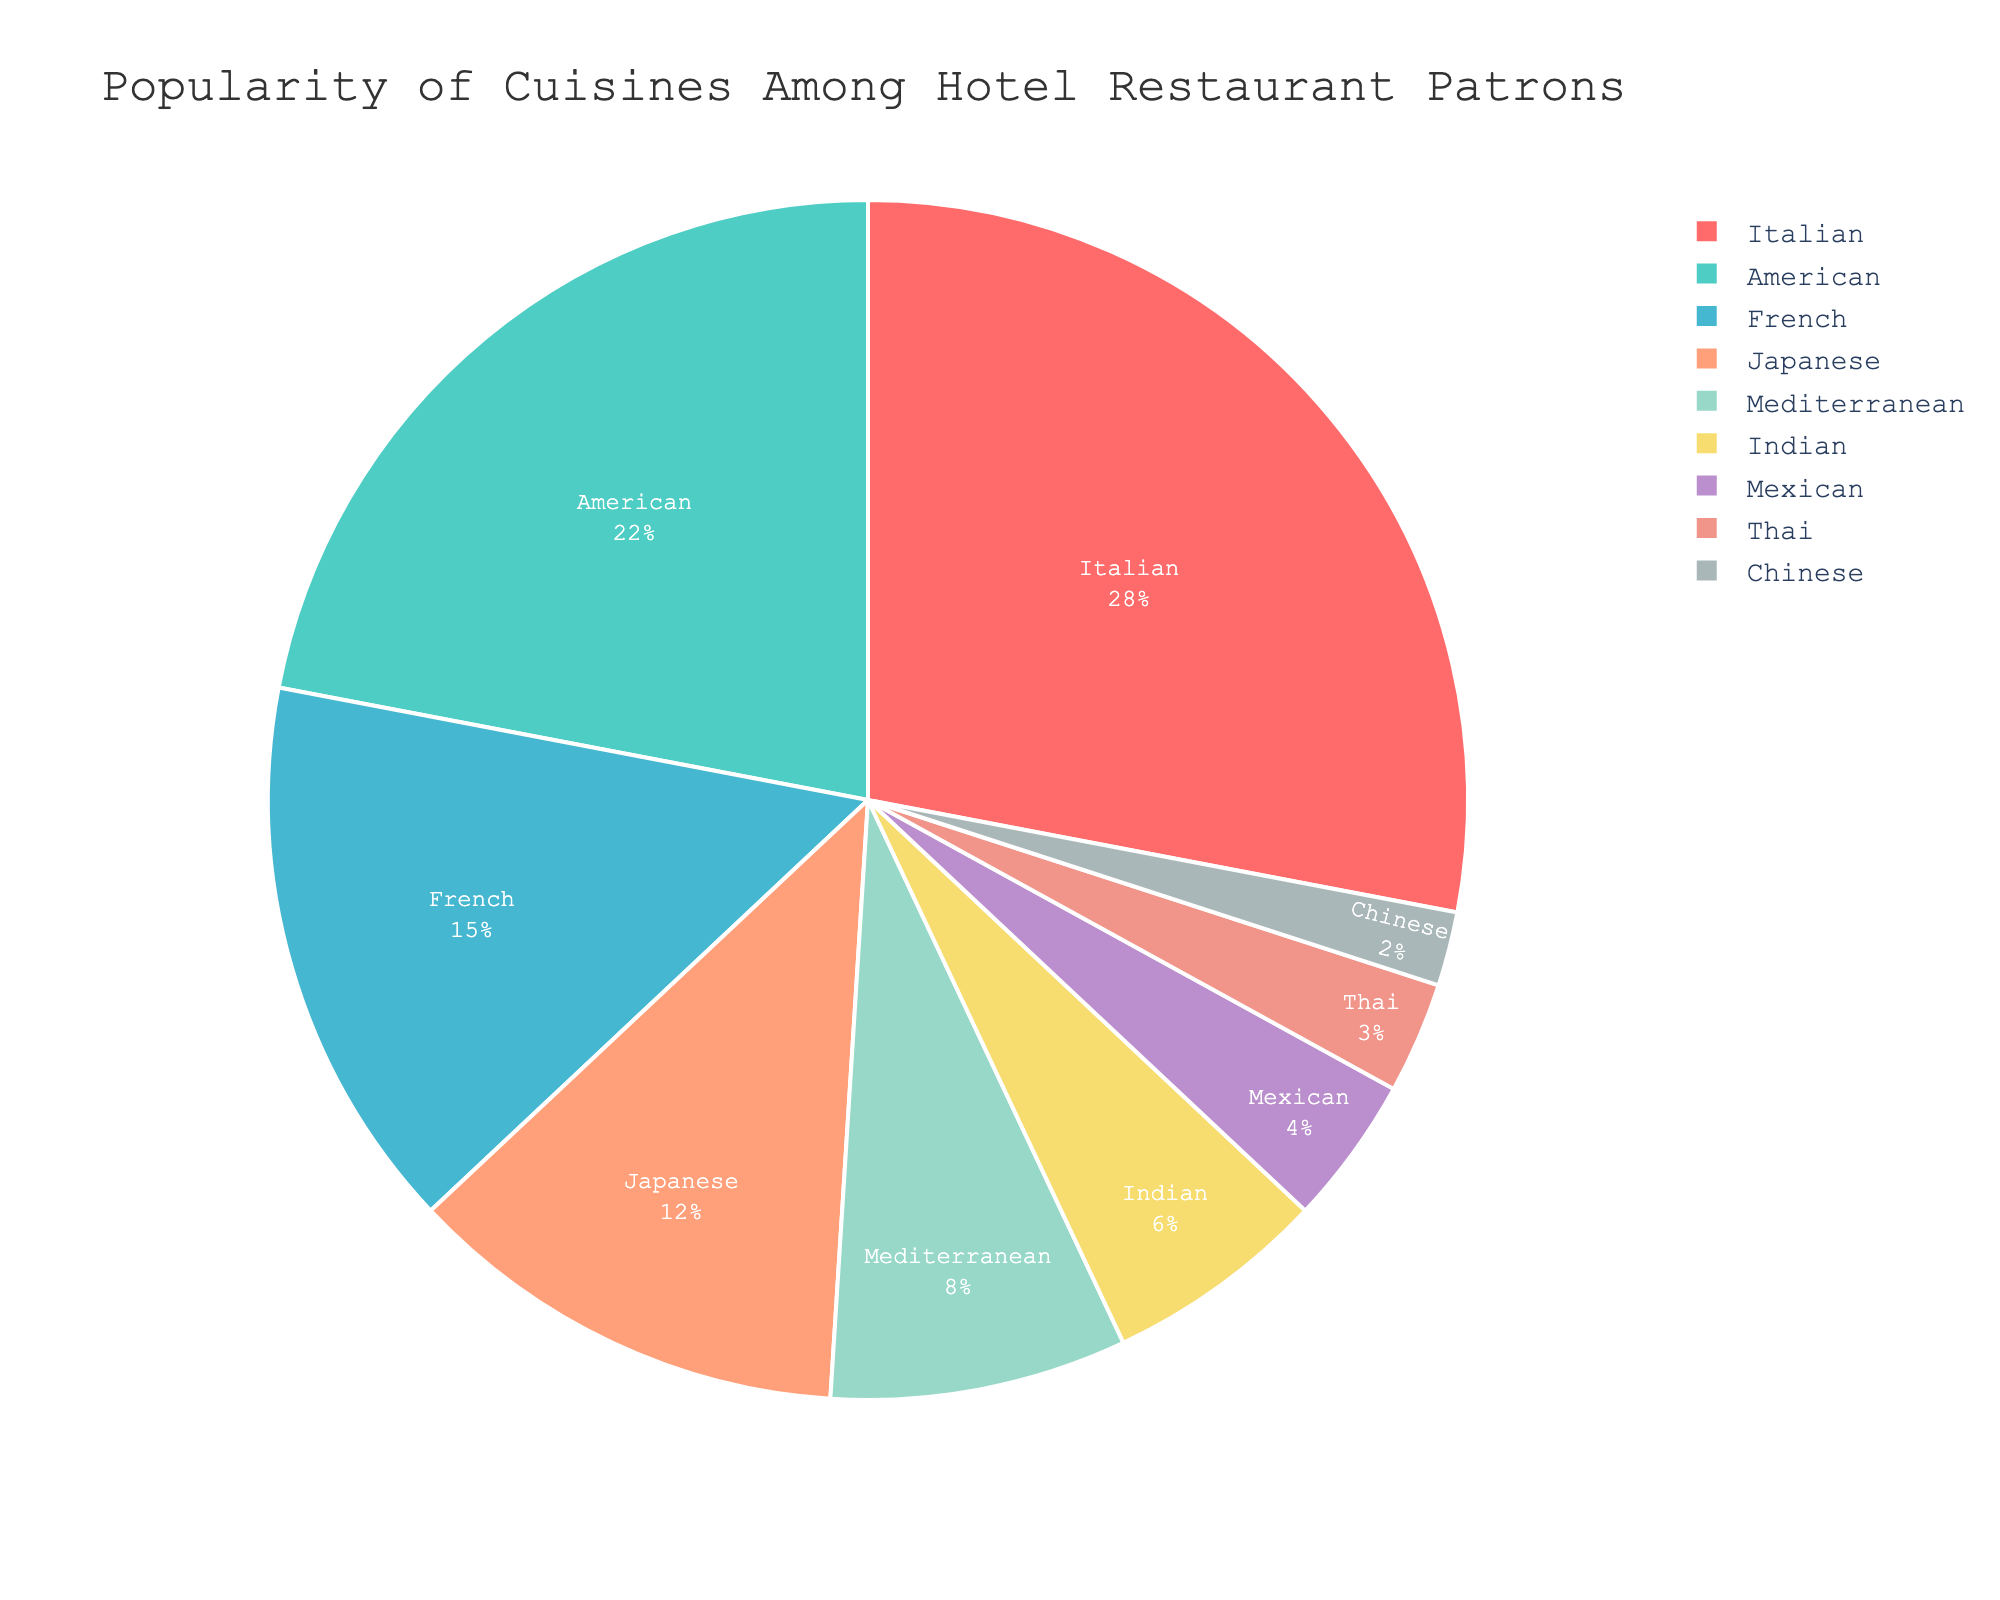How many cuisines have a popularity percentage lower than 10%? To find this, locate all the slices of the pie chart representing cuisines with percentages less than 10. These cuisines are Indian (6%), Mexican (4%), Thai (3%), and Chinese (2%). That makes a total of 4 cuisines.
Answer: 4 Which cuisine is the least popular among hotel restaurant patrons? The least popular cuisine will be the one with the smallest slice in the pie chart. According to the data, Chinese cuisine has the smallest percentage, which is 2%.
Answer: Chinese What is the combined popularity percentage of French and Japanese cuisines? To find the total popularity of French and Japanese cuisines, add their individual percentages: French (15%) + Japanese (12%) = 27%.
Answer: 27% Are there more patrons who prefer American cuisine than those who prefer Japanese and Mediterranean combined? First, check the percentage for American cuisine, which is 22%. Then, add the percentages for Japanese and Mediterranean cuisines: 12% + 8% = 20%. Since 22% (American) > 20% (Japanese + Mediterranean), more patrons prefer American cuisine.
Answer: Yes Which color is used to represent Thai cuisine? Look for the color corresponding to Thai cuisine in the pie chart legend or the pie slices. According to the data, Thai cuisine is marked by a specific color.
Answer: Depends on the chart Is the proportion of patrons preferring Italian cuisine greater than the combined total for Indian, Mexican, Thai, and Chinese cuisines? Calculate the total percentages for Indian (6%), Mexican (4%), Thai (3%), and Chinese (2%): 6% + 4% + 3% + 2% = 15%. Italian cuisine is 28%, which is greater than 15%.
Answer: Yes How does the popularity of Mediterranean cuisine compare to Indian cuisine? Compare the percentages: Mediterranean (8%) versus Indian (6%). Mediterranean is more popular since 8% > 6%.
Answer: Mediterranean is more popular Which cuisine occupies the largest slice on the pie chart? The largest slice will correspond to the cuisine with the highest popularity percentage. According to the data, Italian cuisine, with 28%, occupies the largest slice.
Answer: Italian What is the average percentage popularity of French, Mediterranean, and Indian cuisines? Sum the percentages for French (15%), Mediterranean (8%), and Indian (6%), and then divide by the number of cuisines: (15% + 8% + 6%) / 3 = 29% / 3 ≈ 9.67%.
Answer: 9.67% If you combine the popularity of Mediterranean and Mexican cuisines, is it higher than French cuisine alone? Add the percentages for Mediterranean (8%) and Mexican (4%) then compare with that of French (15%): 8% + 4% = 12%, which is less than 15%.
Answer: No 